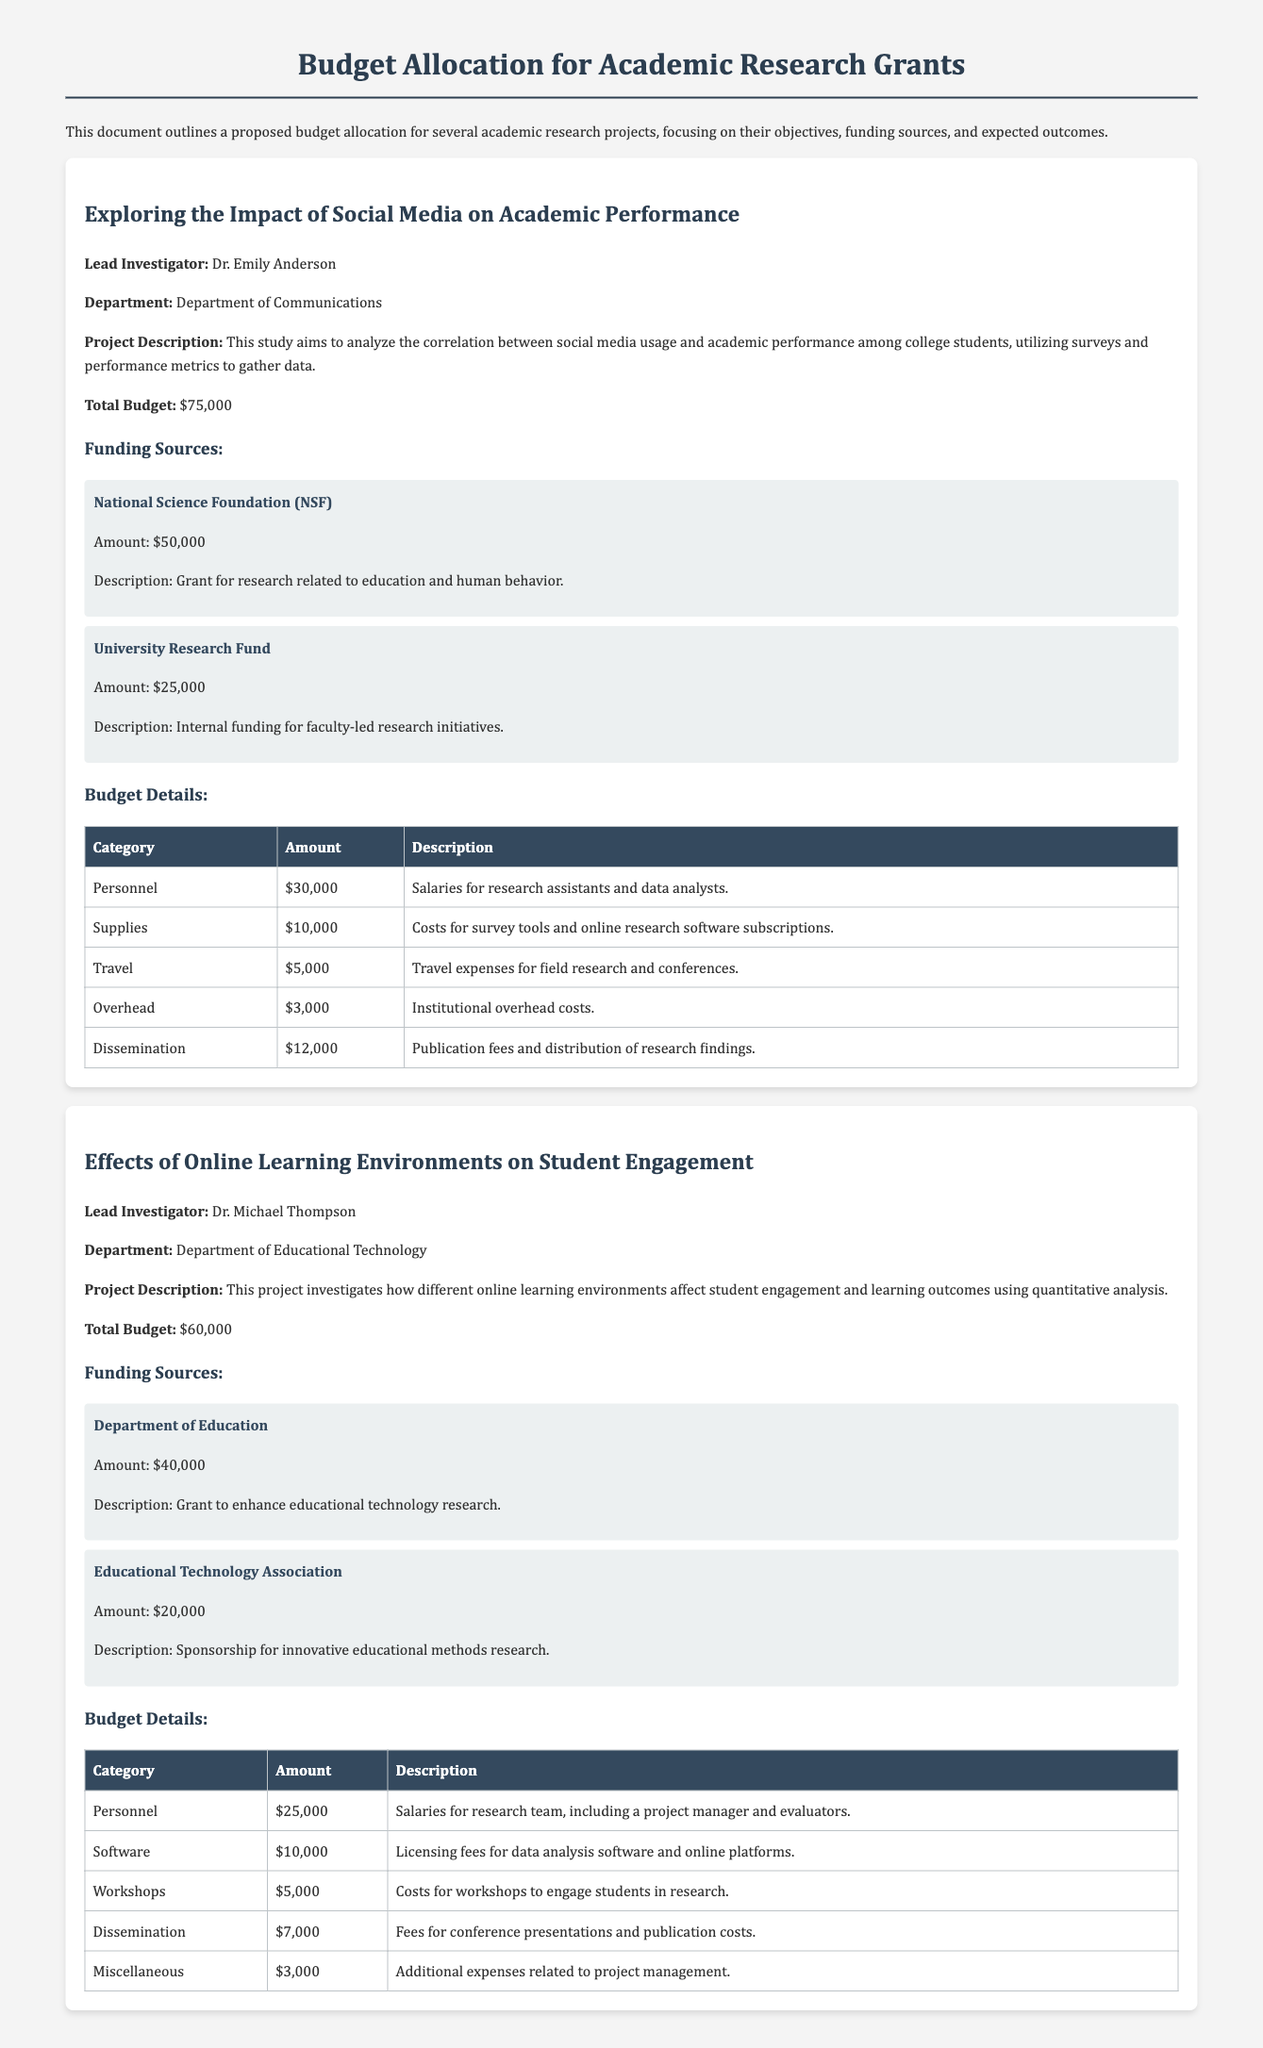What is the total budget for the project on social media? The total budget for the social media project is stated in the document, which is $75,000.
Answer: $75,000 Who is the lead investigator for the online learning project? The document provides the name of the lead investigator for the online learning project as Dr. Michael Thompson.
Answer: Dr. Michael Thompson What is the amount provided by the National Science Foundation? According to the funding sources listed, the amount provided by the National Science Foundation is $50,000.
Answer: $50,000 What category has the highest budget allocation in the social media project? By examining the budget details, it is clear that the highest allocation is for Personnel, which is $30,000.
Answer: Personnel How much funding is provided by the Department of Education? The document specifies that the funding from the Department of Education is $40,000.
Answer: $40,000 What is the purpose of the dissemination budget category? The dissemination budget category is explained in the document as covering publication fees and distribution of research findings.
Answer: Publication fees and distribution of research findings How many funding sources are listed for the effects of online learning project? The document lists two funding sources for the effects of online learning project.
Answer: Two What is the total budget for the project on online learning environments? The total budget for the online learning project is stated to be $60,000 in the document.
Answer: $60,000 